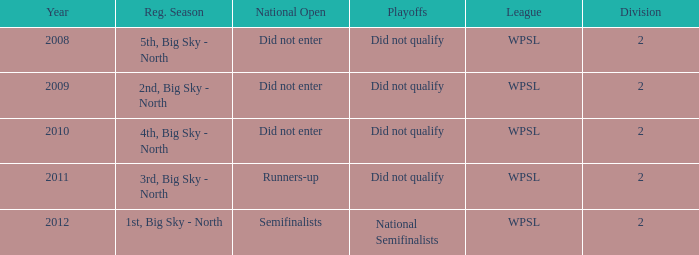What is the lowest division number? 2.0. 